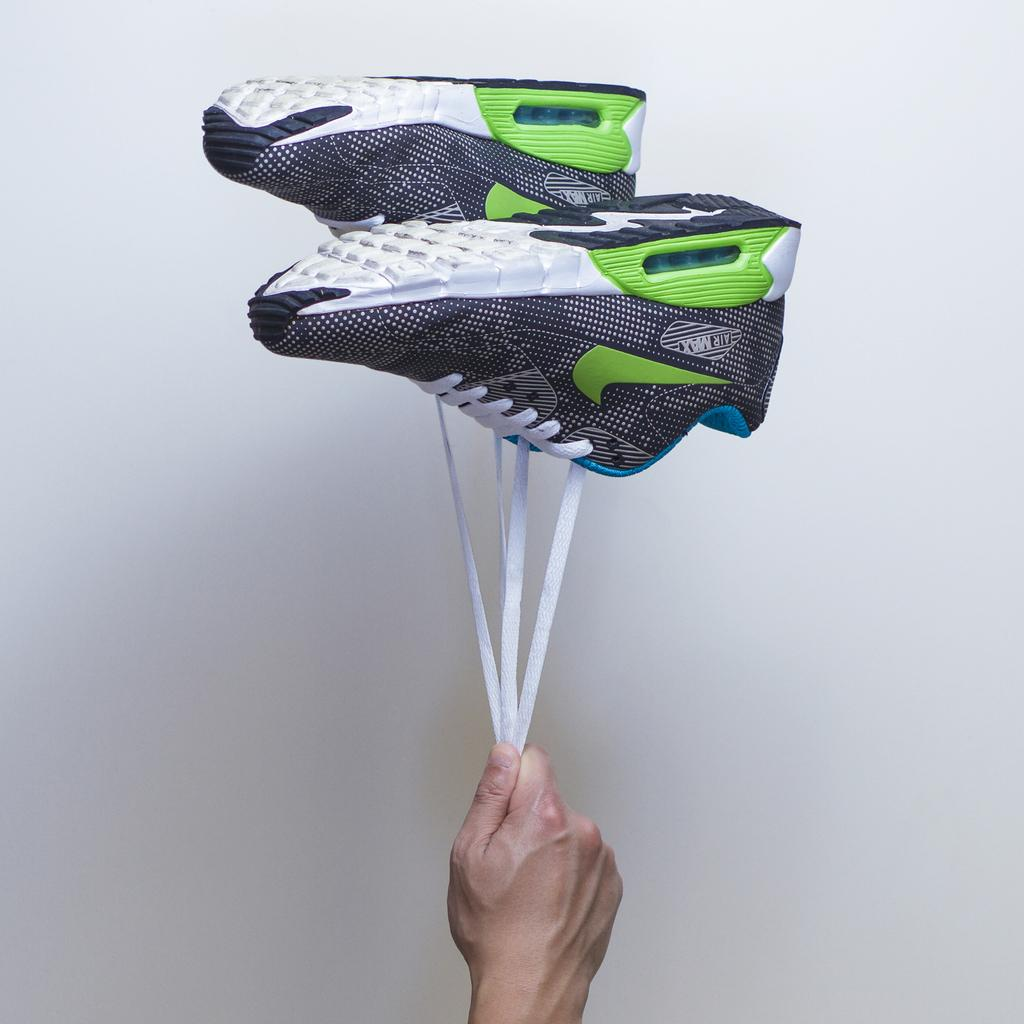What part of a person's body is visible in the image? A: There is a person's hand in the image. What type of shoes can be seen in the image? There are shoes with laces in the image. What type of land can be seen in the image? There is no land visible in the image; it only shows a person's hand and shoes with laces. What order are the shoes arranged in the image? The shoes are not arranged in any specific order in the image; they are simply visible. 